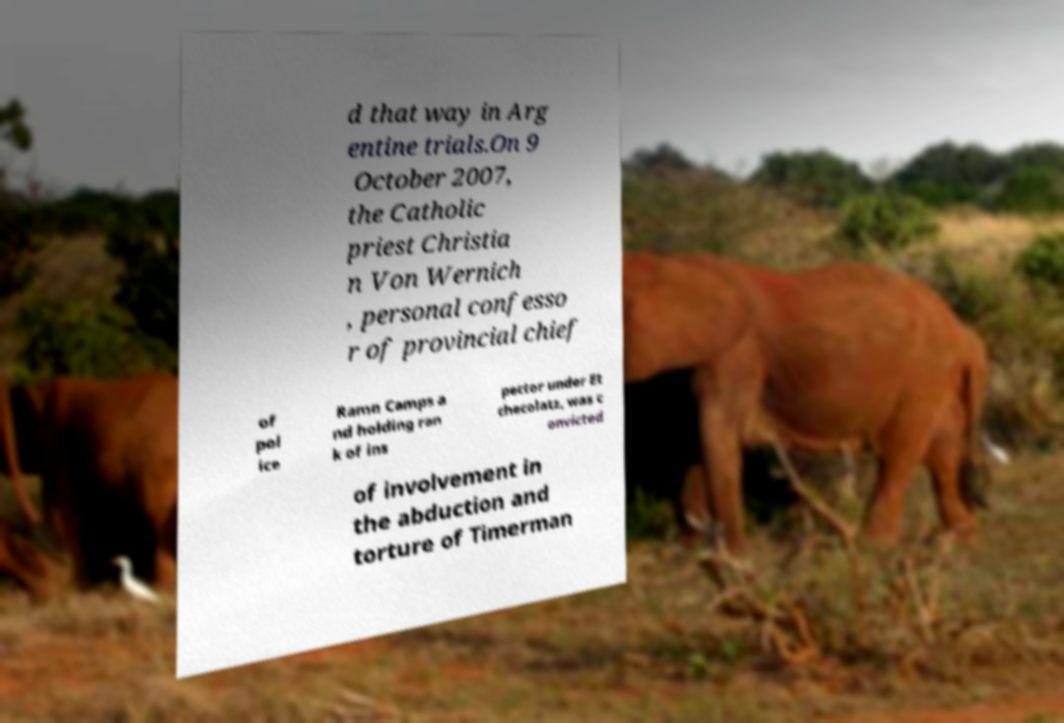Please identify and transcribe the text found in this image. d that way in Arg entine trials.On 9 October 2007, the Catholic priest Christia n Von Wernich , personal confesso r of provincial chief of pol ice Ramn Camps a nd holding ran k of ins pector under Et checolatz, was c onvicted of involvement in the abduction and torture of Timerman 